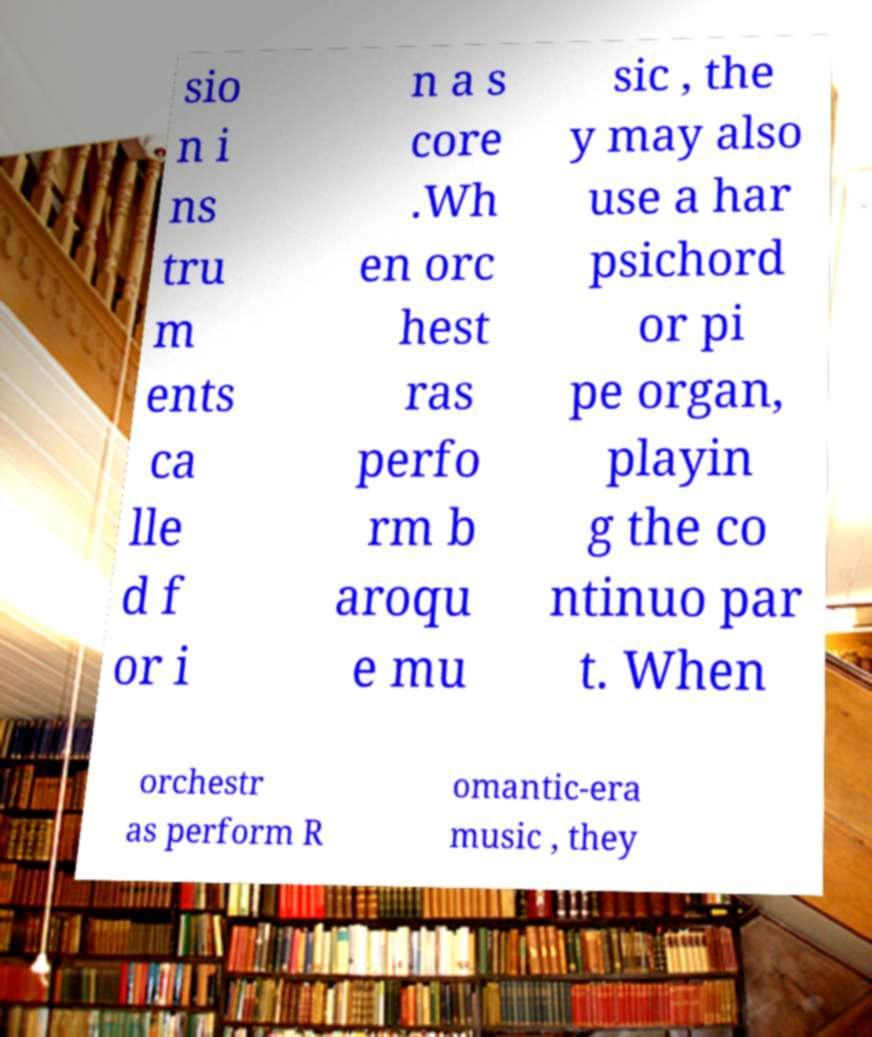There's text embedded in this image that I need extracted. Can you transcribe it verbatim? sio n i ns tru m ents ca lle d f or i n a s core .Wh en orc hest ras perfo rm b aroqu e mu sic , the y may also use a har psichord or pi pe organ, playin g the co ntinuo par t. When orchestr as perform R omantic-era music , they 